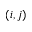Convert formula to latex. <formula><loc_0><loc_0><loc_500><loc_500>( i , j )</formula> 